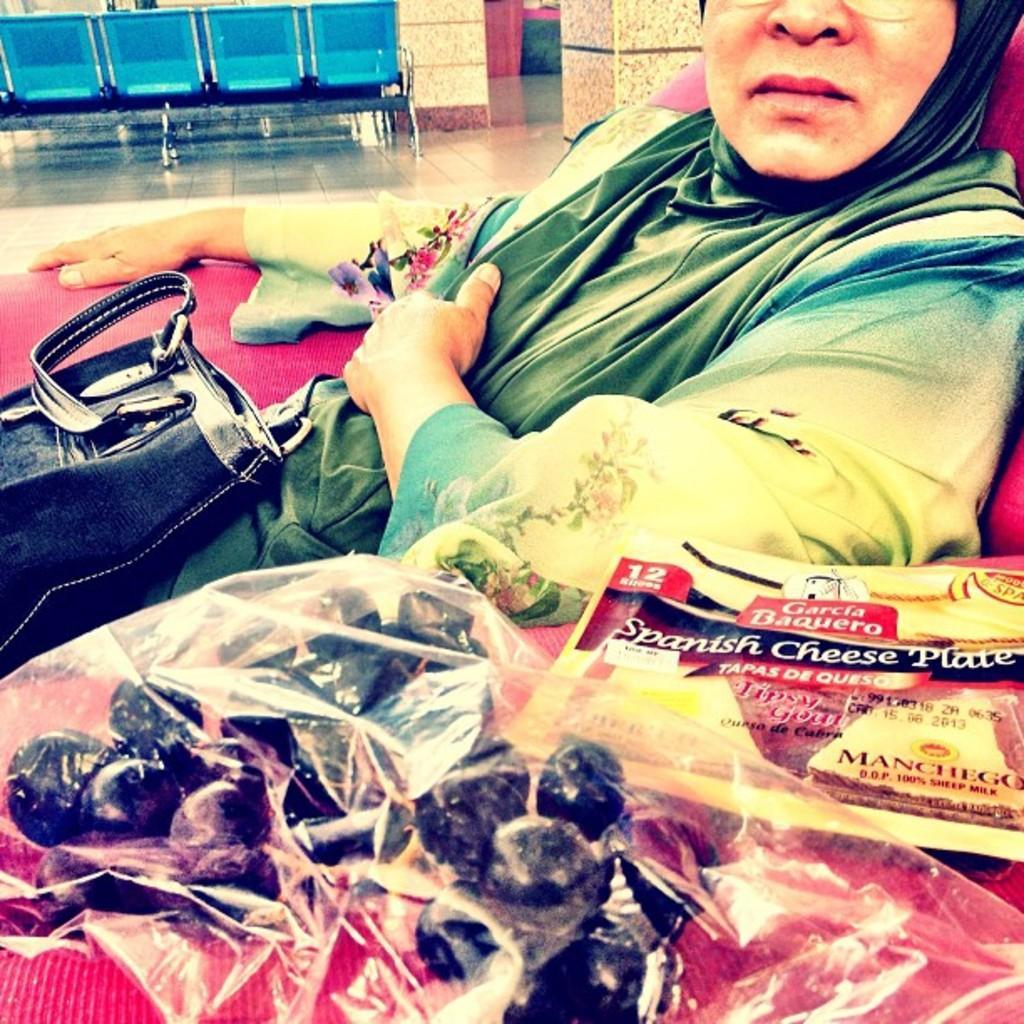Describe this image in one or two sentences. In this image I see a woman who is sitting on this red color couch and I see a black color bag on her and I see covers over here and I see something is written on this cover here. In the background I see the wall, path and 4 blue color chairs. 